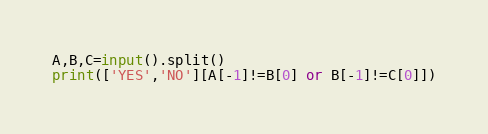<code> <loc_0><loc_0><loc_500><loc_500><_Python_>A,B,C=input().split()
print(['YES','NO'][A[-1]!=B[0] or B[-1]!=C[0]])</code> 